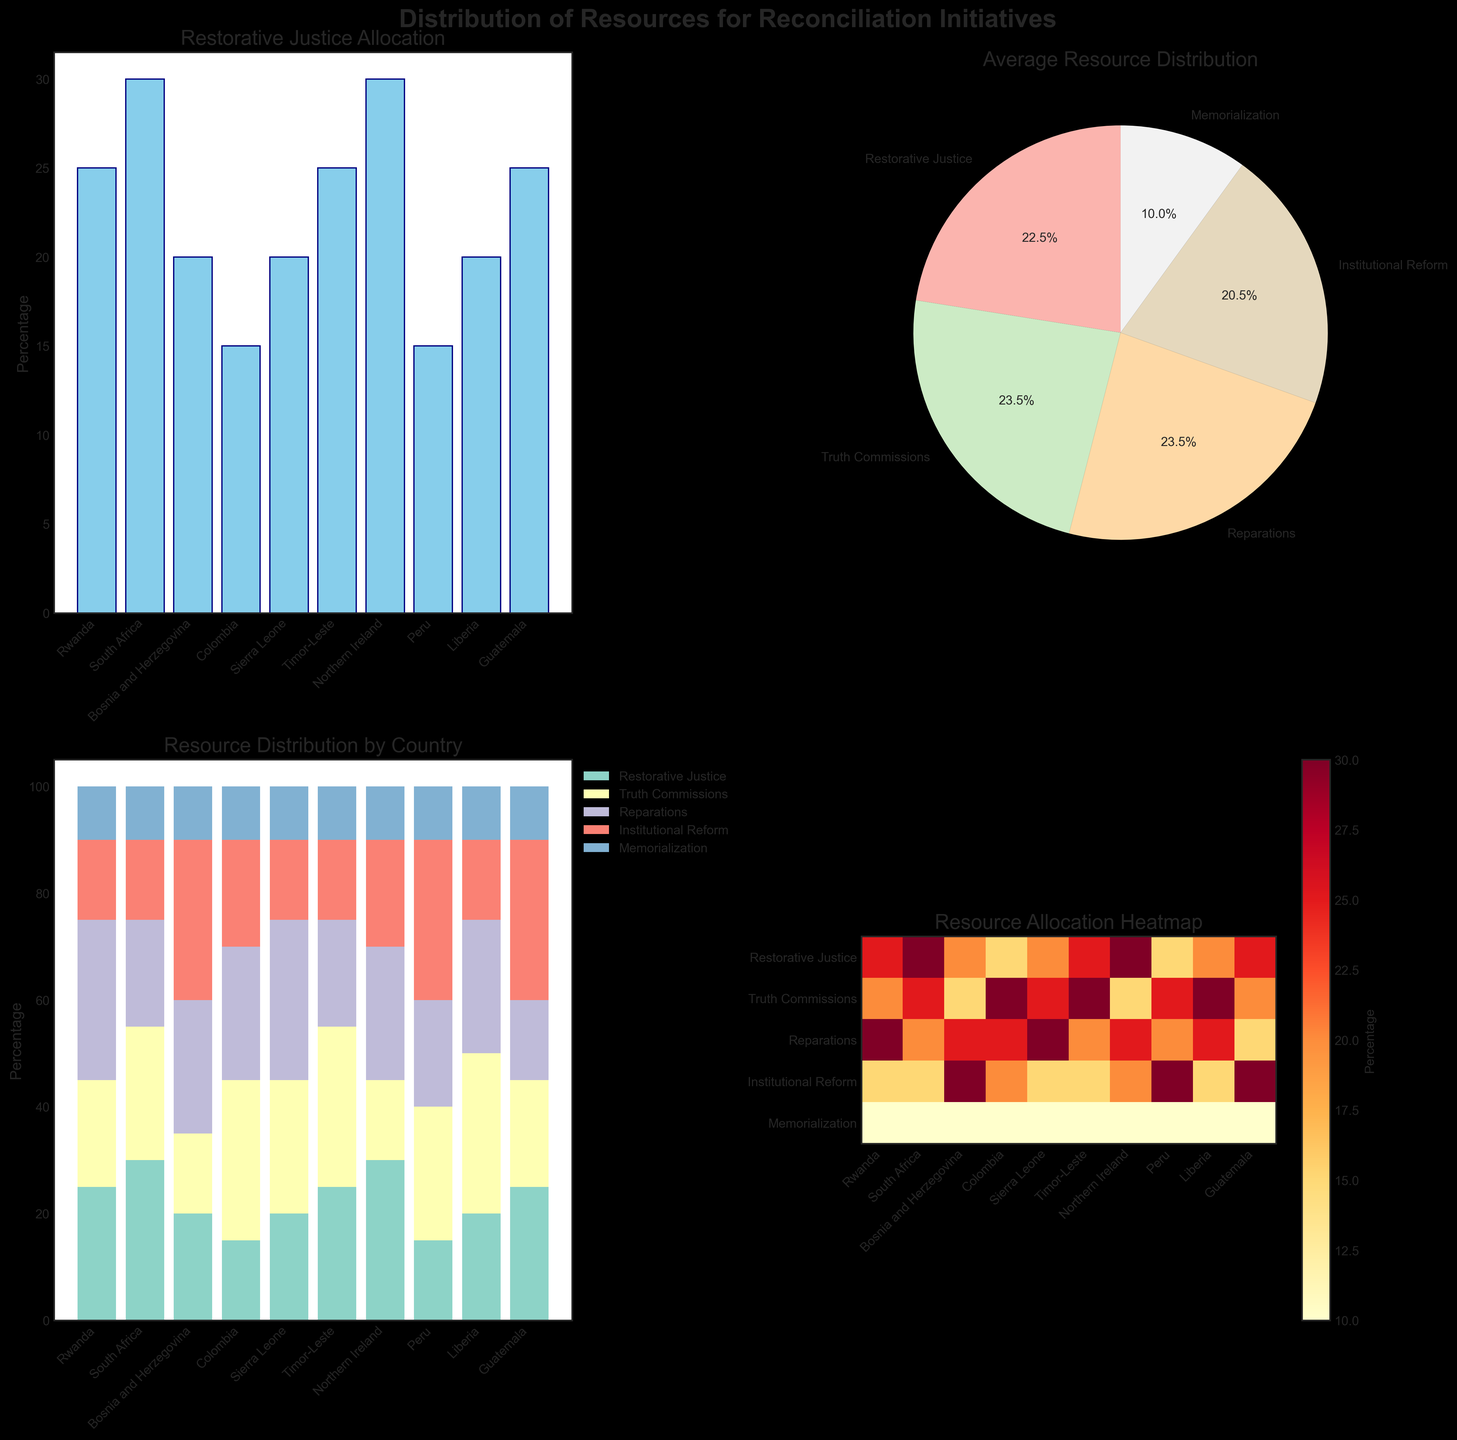What is the percentage of resources allocated to Restorative Justice in Rwanda? Look at the bar plot in the top left corner, find the bar for Rwanda, and read its height.
Answer: 25% Which reconciliation initiative has the highest average resource allocation? Refer to the pie chart in the top right corner. The largest slice represents the category with the highest average allocation.
Answer: Reparations How does the allocation of resources for Truth Commissions in Colombia compare to Sierra Leone? Look at the bar heights for Truth Commissions in both countries from the bar plot or the stacked bar chart. Compare the two heights.
Answer: Colombia has a higher allocation (30% vs. 25%) In the heatmap, which country has the highest allocation for Institutional Reform? Identify the highest value in the Institutional Reform row of the heatmap and find the corresponding country on the x-axis.
Answer: Guatemala and Peru (both 30%) What is the combined total percentage of resources allocated to Memorialization across all countries? Observe the percentage for Memorialization across all countries either in the data table or stacked bar chart, add them up: 10% for each of the 10 countries.
Answer: 100% Which country shows the most balanced resource allocation across all reconciliation initiatives? Check the heatmap and look for the country with the most even distribution of values.
Answer: Northern Ireland What is the difference in resource allocation for Reparations between Bosnia and Herzegovina, and Timor-Leste? Locate the values for Reparations for both countries (25% for Bosnia and Herzegovina and 20% for Timor-Leste) and subtract one from the other.
Answer: 5% Which initiative has the lowest average resource allocation? Check the pie chart and identify the smallest slice.
Answer: Memorialization How many countries allocate 30% of their resources to Truth Commissions? Look at either the bar plot, the stacked bar chart, or the values in the data table for Truth Commissions. Count the countries that allocate 30%.
Answer: Three countries (Colombia, Timor-Leste, Liberia) What is the percentage difference in Restorative Justice allocation between Northern Ireland and South Africa? Check the values for Restorative Justice in both countries (30% for Northern Ireland and 30% for South Africa). Subtract one from the other.
Answer: 0% 